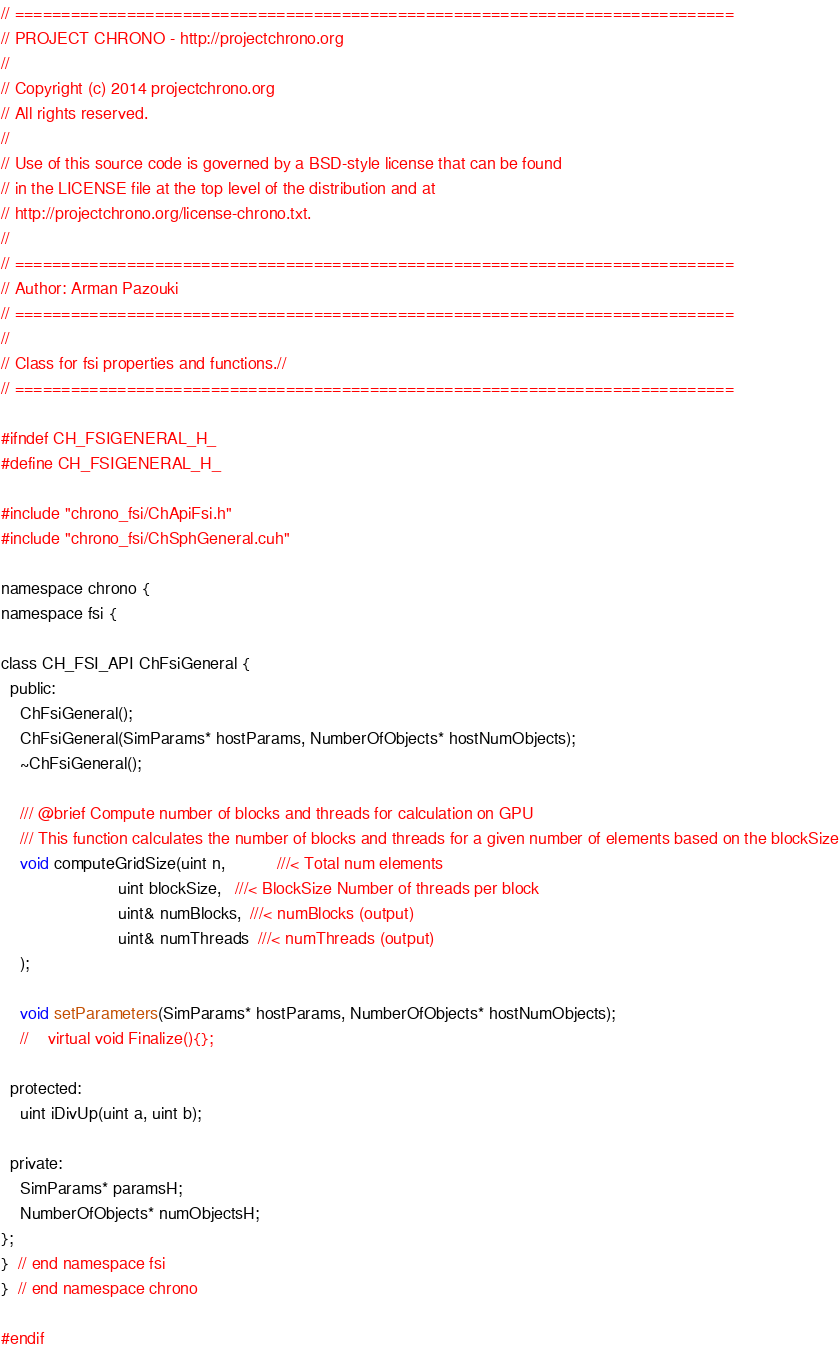Convert code to text. <code><loc_0><loc_0><loc_500><loc_500><_Cuda_>// =============================================================================
// PROJECT CHRONO - http://projectchrono.org
//
// Copyright (c) 2014 projectchrono.org
// All rights reserved.
//
// Use of this source code is governed by a BSD-style license that can be found
// in the LICENSE file at the top level of the distribution and at
// http://projectchrono.org/license-chrono.txt.
//
// =============================================================================
// Author: Arman Pazouki
// =============================================================================
//
// Class for fsi properties and functions.//
// =============================================================================

#ifndef CH_FSIGENERAL_H_
#define CH_FSIGENERAL_H_

#include "chrono_fsi/ChApiFsi.h"
#include "chrono_fsi/ChSphGeneral.cuh"

namespace chrono {
namespace fsi {

class CH_FSI_API ChFsiGeneral {
  public:
    ChFsiGeneral();
    ChFsiGeneral(SimParams* hostParams, NumberOfObjects* hostNumObjects);
    ~ChFsiGeneral();

    /// @brief Compute number of blocks and threads for calculation on GPU
    /// This function calculates the number of blocks and threads for a given number of elements based on the blockSize
    void computeGridSize(uint n,           ///< Total num elements
                         uint blockSize,   ///< BlockSize Number of threads per block
                         uint& numBlocks,  ///< numBlocks (output)
                         uint& numThreads  ///< numThreads (output)
    );

    void setParameters(SimParams* hostParams, NumberOfObjects* hostNumObjects);
    //    virtual void Finalize(){};

  protected:
    uint iDivUp(uint a, uint b);

  private:
    SimParams* paramsH;
    NumberOfObjects* numObjectsH;
};
}  // end namespace fsi
}  // end namespace chrono

#endif
</code> 